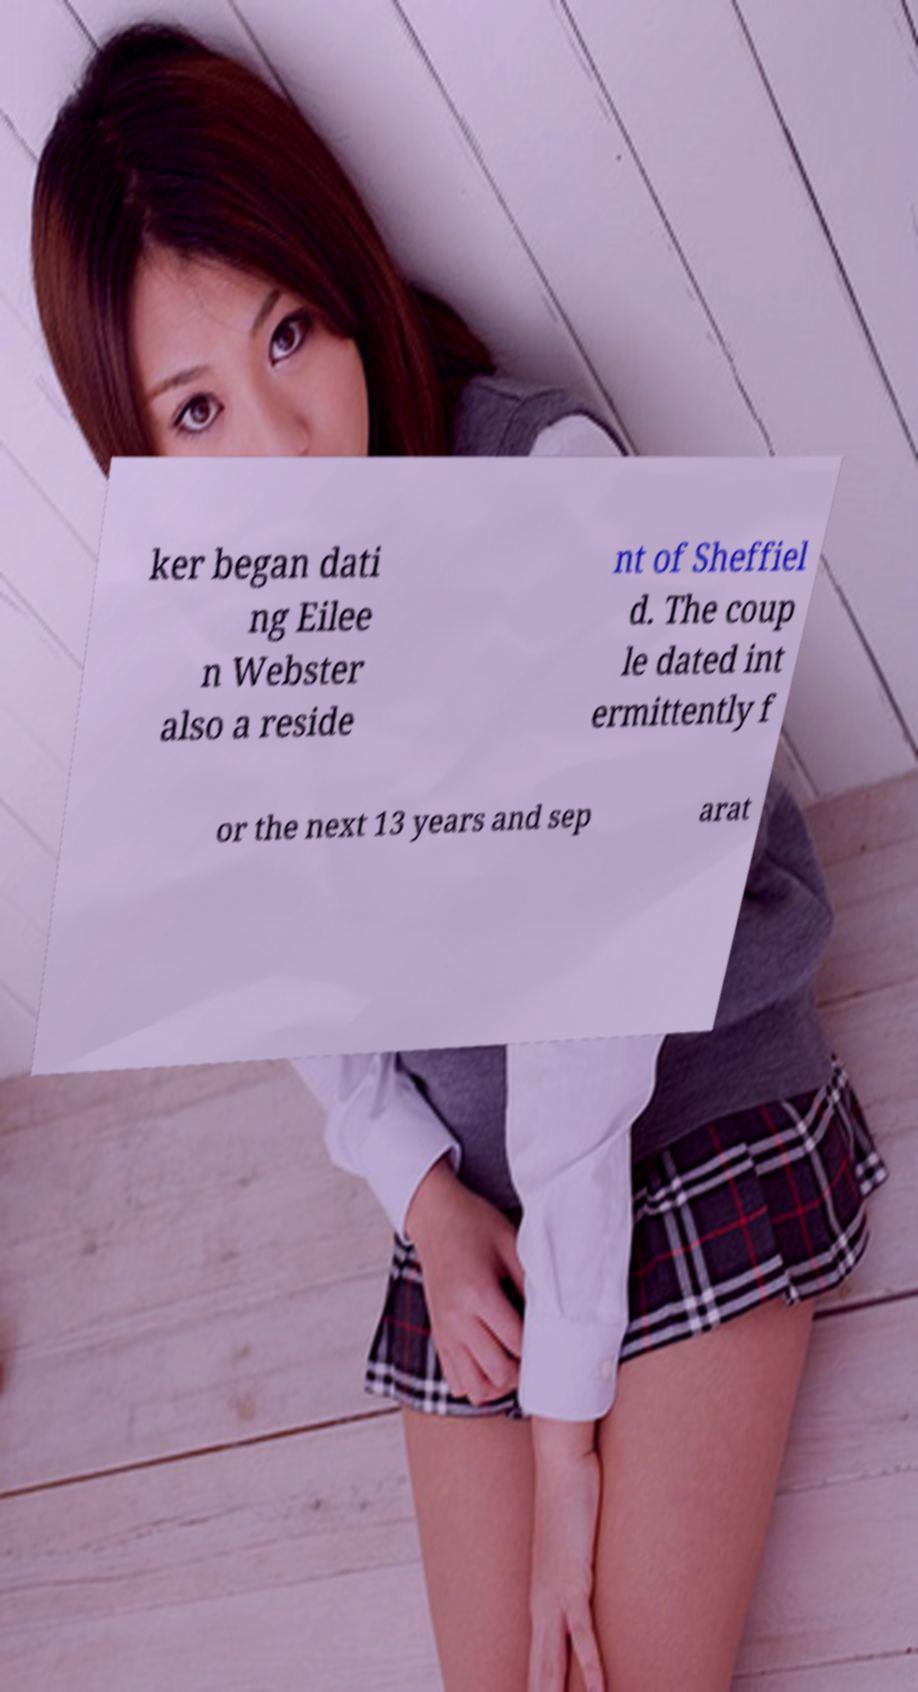For documentation purposes, I need the text within this image transcribed. Could you provide that? ker began dati ng Eilee n Webster also a reside nt of Sheffiel d. The coup le dated int ermittently f or the next 13 years and sep arat 